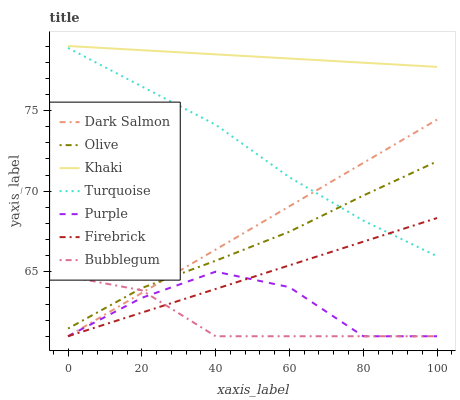Does Bubblegum have the minimum area under the curve?
Answer yes or no. Yes. Does Khaki have the maximum area under the curve?
Answer yes or no. Yes. Does Purple have the minimum area under the curve?
Answer yes or no. No. Does Purple have the maximum area under the curve?
Answer yes or no. No. Is Firebrick the smoothest?
Answer yes or no. Yes. Is Purple the roughest?
Answer yes or no. Yes. Is Khaki the smoothest?
Answer yes or no. No. Is Khaki the roughest?
Answer yes or no. No. Does Purple have the lowest value?
Answer yes or no. Yes. Does Khaki have the lowest value?
Answer yes or no. No. Does Khaki have the highest value?
Answer yes or no. Yes. Does Purple have the highest value?
Answer yes or no. No. Is Bubblegum less than Turquoise?
Answer yes or no. Yes. Is Khaki greater than Purple?
Answer yes or no. Yes. Does Dark Salmon intersect Bubblegum?
Answer yes or no. Yes. Is Dark Salmon less than Bubblegum?
Answer yes or no. No. Is Dark Salmon greater than Bubblegum?
Answer yes or no. No. Does Bubblegum intersect Turquoise?
Answer yes or no. No. 